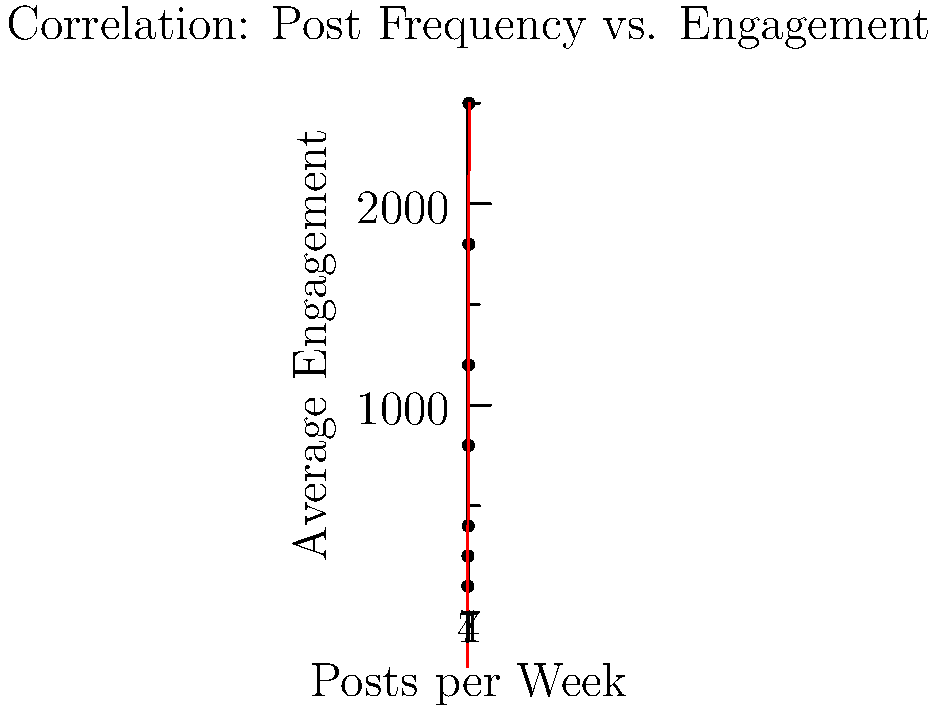As a social media influencer, you've been tracking your post frequency and engagement rates. The scatter plot shows the relationship between your weekly post frequency and average engagement. Based on the trend line, what is the approximate increase in average engagement for each additional post per week? To solve this problem, we need to analyze the trend line in the scatter plot. Here's a step-by-step approach:

1. Observe that the trend line is linear, indicating a positive correlation between post frequency and engagement.

2. The trend line can be represented by the equation $y = mx + b$, where:
   - $y$ is the average engagement
   - $x$ is the number of posts per week
   - $m$ is the slope (which represents the increase in engagement per additional post)
   - $b$ is the y-intercept

3. To find the slope, we can choose two points on the line:
   - At $x = 0$, $y \approx -300$
   - At $x = 8$, $y \approx 2500$

4. Calculate the slope using the formula:
   $m = \frac{y_2 - y_1}{x_2 - x_1} = \frac{2500 - (-300)}{8 - 0} = \frac{2800}{8} = 350$

5. Therefore, the slope of the trend line is approximately 350.

This means that for each additional post per week, the average engagement increases by about 350 units.
Answer: 350 engagement units per additional post 